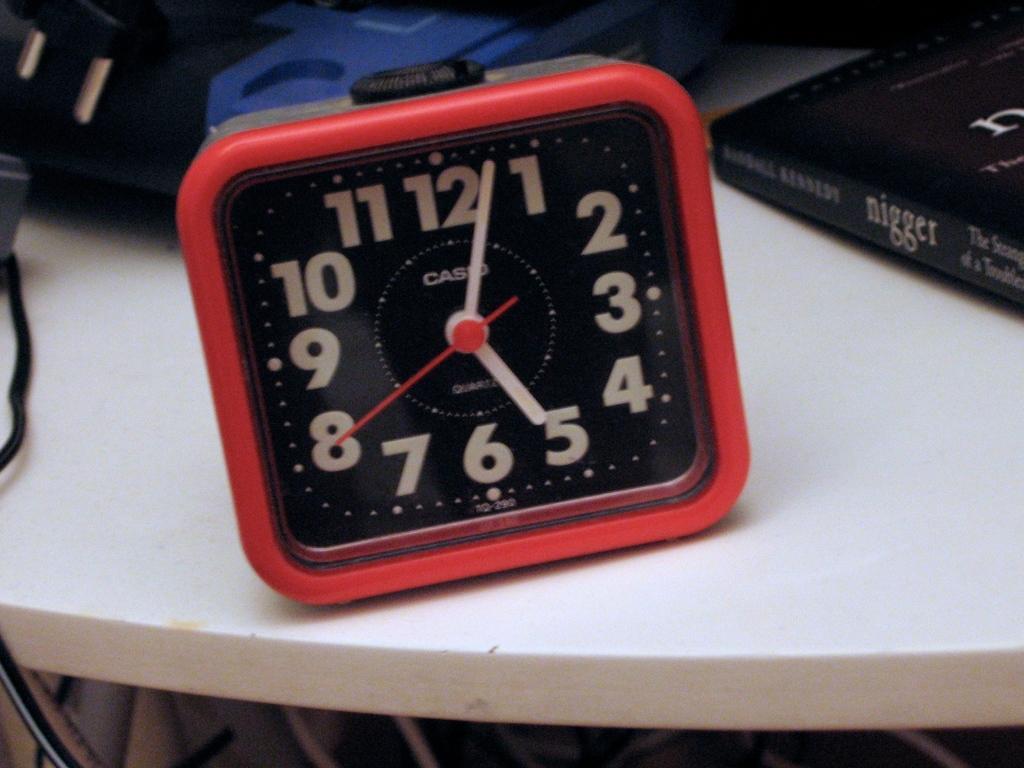How would you summarize this image in a sentence or two? In this image we can see clock, book placed on the table. 